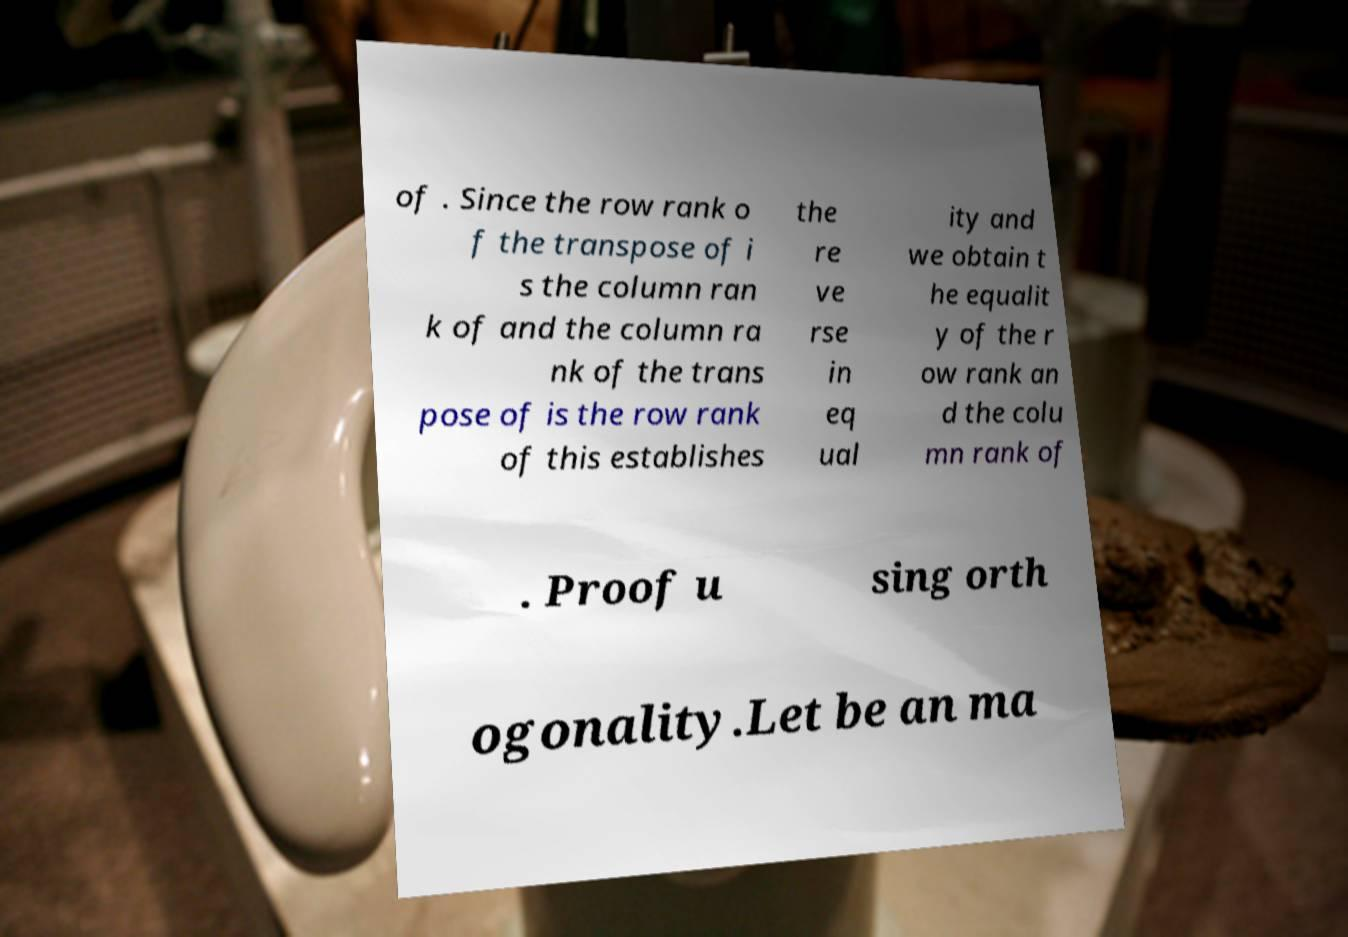Could you extract and type out the text from this image? of . Since the row rank o f the transpose of i s the column ran k of and the column ra nk of the trans pose of is the row rank of this establishes the re ve rse in eq ual ity and we obtain t he equalit y of the r ow rank an d the colu mn rank of . Proof u sing orth ogonality.Let be an ma 